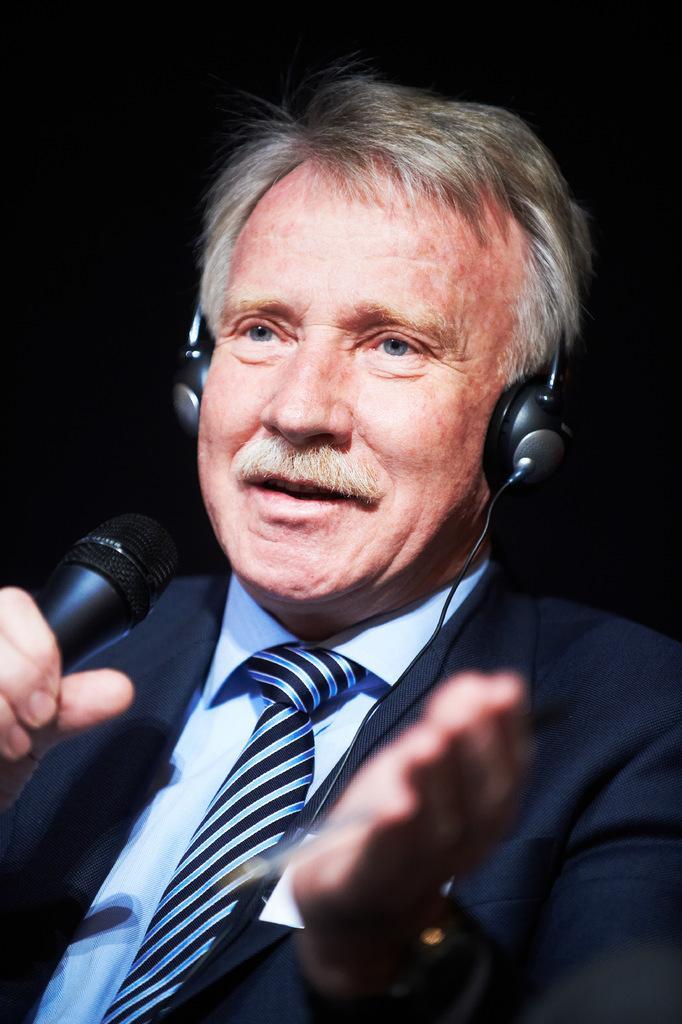Can you describe this image briefly? In this image In the middle there is a man he wears suit, shirt, tie and head set he is holding a mic. 